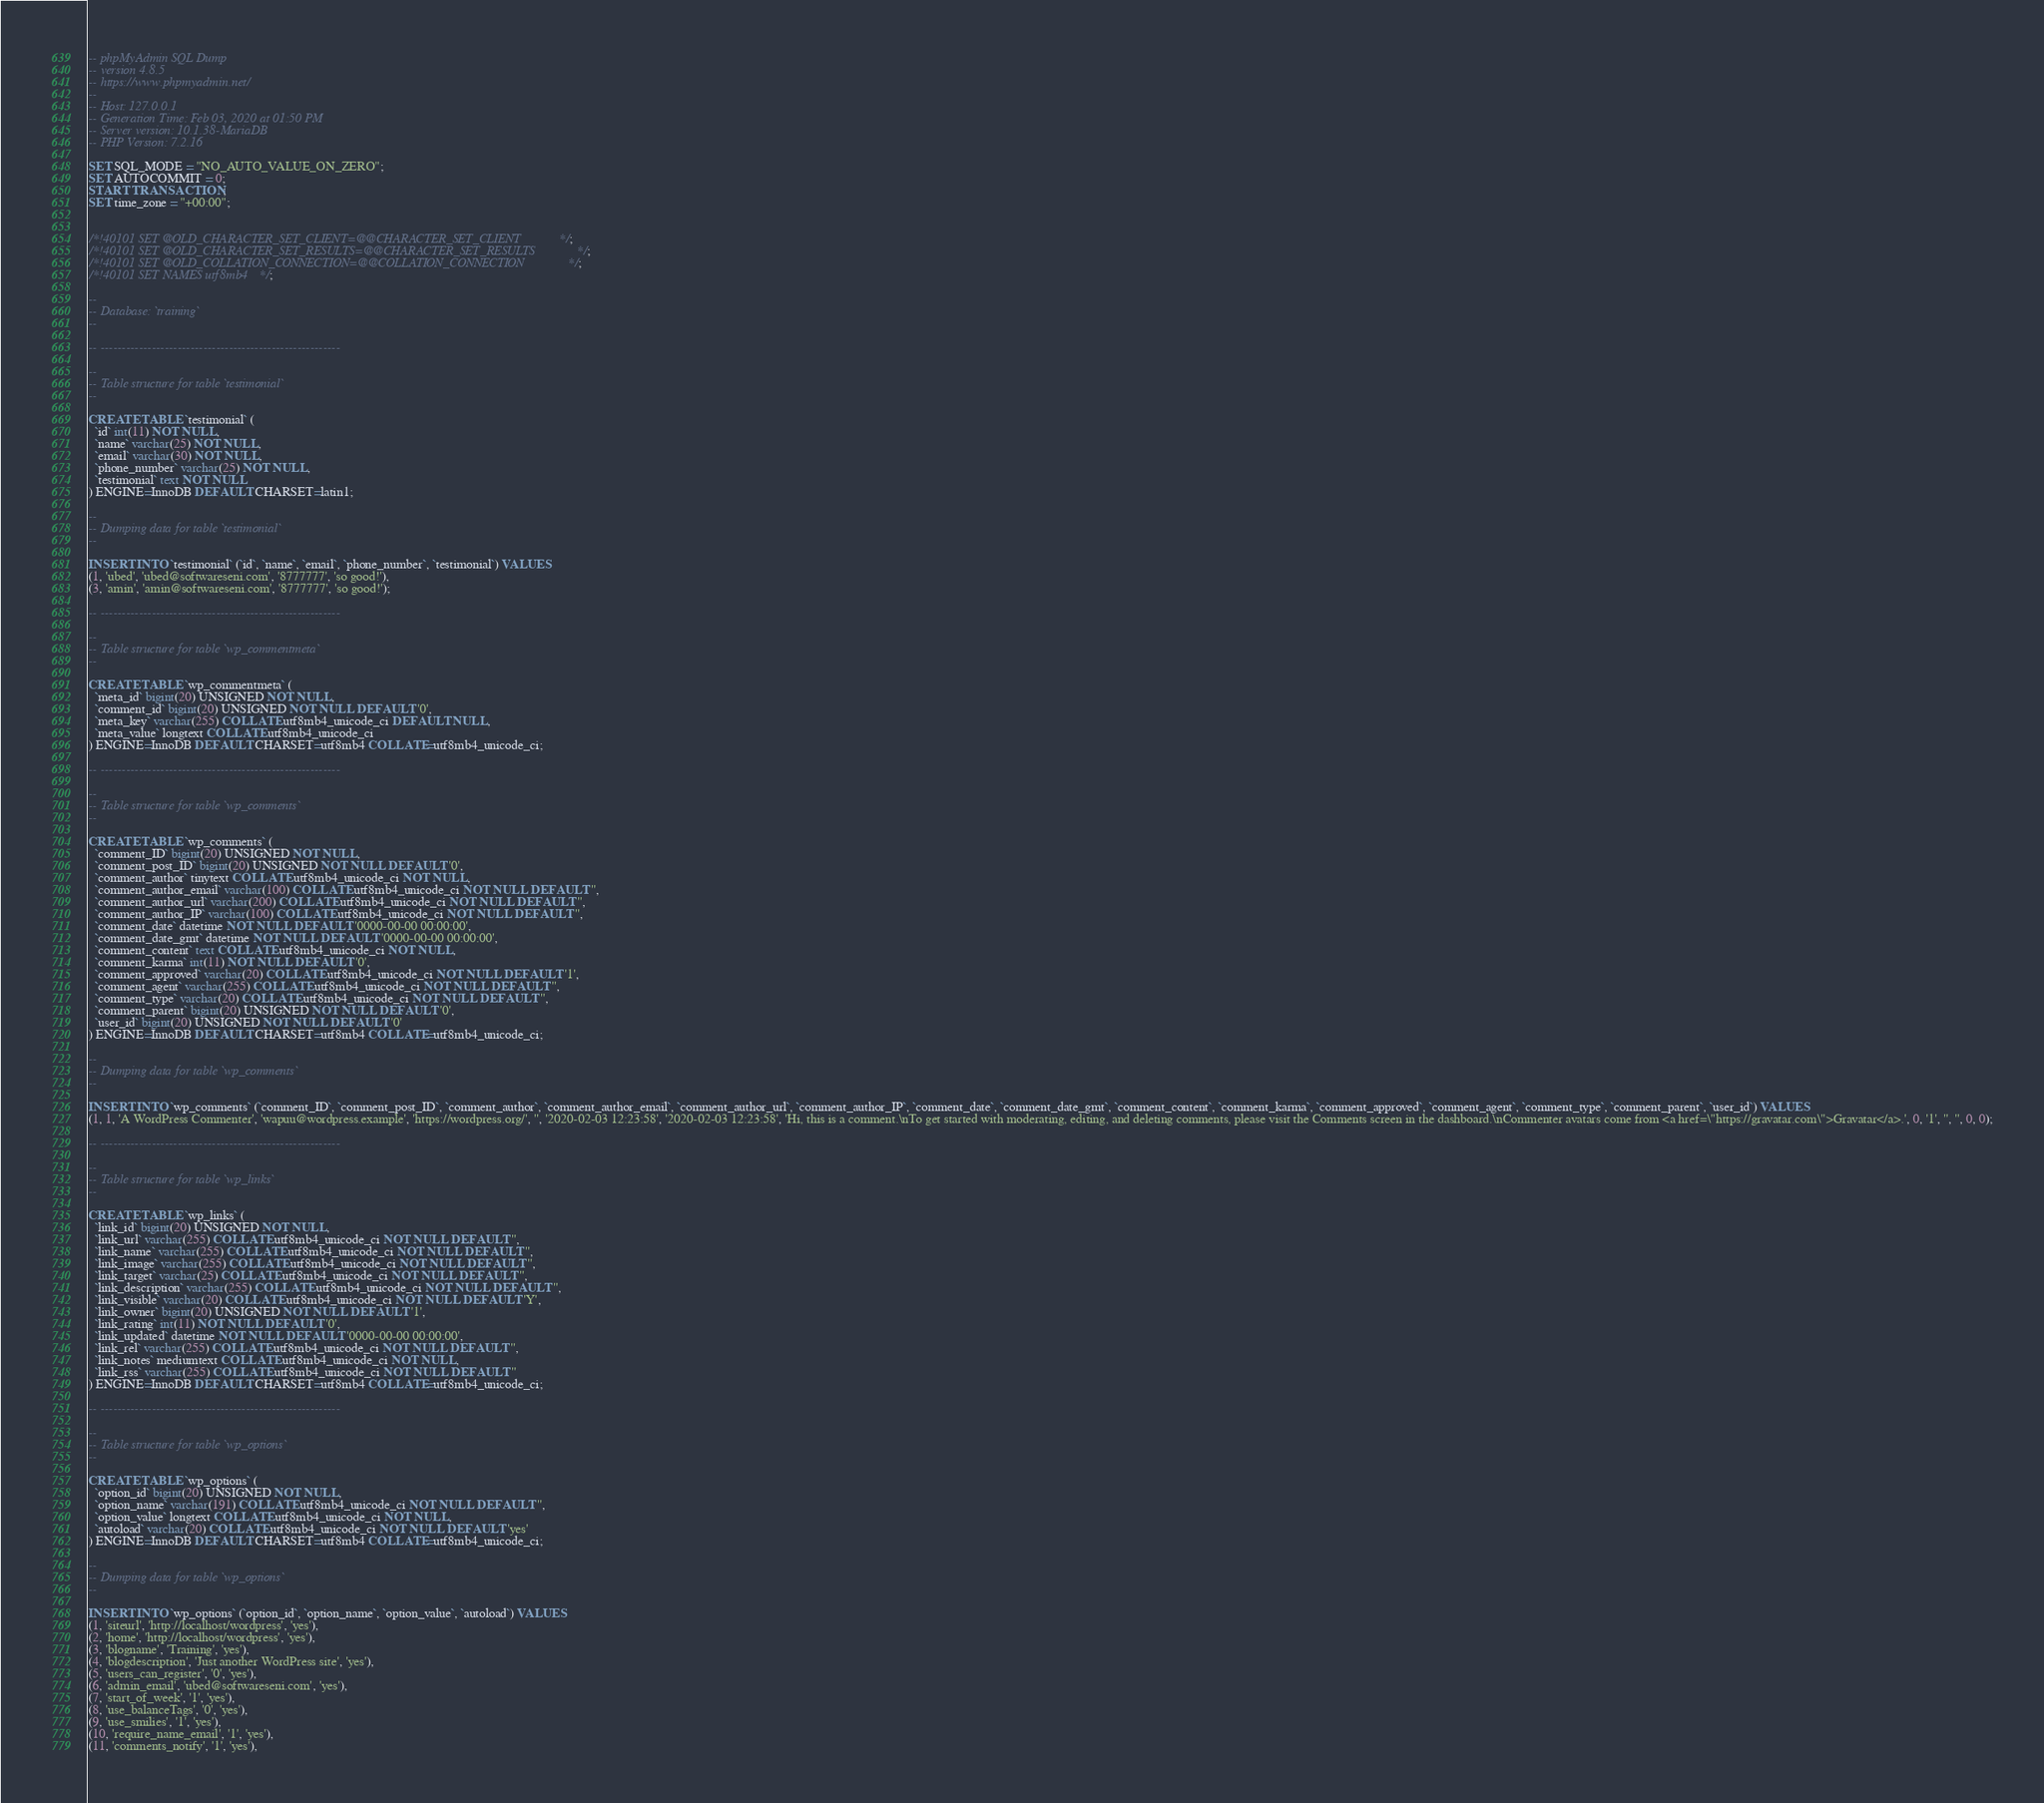Convert code to text. <code><loc_0><loc_0><loc_500><loc_500><_SQL_>-- phpMyAdmin SQL Dump
-- version 4.8.5
-- https://www.phpmyadmin.net/
--
-- Host: 127.0.0.1
-- Generation Time: Feb 03, 2020 at 01:50 PM
-- Server version: 10.1.38-MariaDB
-- PHP Version: 7.2.16

SET SQL_MODE = "NO_AUTO_VALUE_ON_ZERO";
SET AUTOCOMMIT = 0;
START TRANSACTION;
SET time_zone = "+00:00";


/*!40101 SET @OLD_CHARACTER_SET_CLIENT=@@CHARACTER_SET_CLIENT */;
/*!40101 SET @OLD_CHARACTER_SET_RESULTS=@@CHARACTER_SET_RESULTS */;
/*!40101 SET @OLD_COLLATION_CONNECTION=@@COLLATION_CONNECTION */;
/*!40101 SET NAMES utf8mb4 */;

--
-- Database: `training`
--

-- --------------------------------------------------------

--
-- Table structure for table `testimonial`
--

CREATE TABLE `testimonial` (
  `id` int(11) NOT NULL,
  `name` varchar(25) NOT NULL,
  `email` varchar(30) NOT NULL,
  `phone_number` varchar(25) NOT NULL,
  `testimonial` text NOT NULL
) ENGINE=InnoDB DEFAULT CHARSET=latin1;

--
-- Dumping data for table `testimonial`
--

INSERT INTO `testimonial` (`id`, `name`, `email`, `phone_number`, `testimonial`) VALUES
(1, 'ubed', 'ubed@softwareseni.com', '8777777', 'so good!'),
(3, 'amin', 'amin@softwareseni.com', '8777777', 'so good!');

-- --------------------------------------------------------

--
-- Table structure for table `wp_commentmeta`
--

CREATE TABLE `wp_commentmeta` (
  `meta_id` bigint(20) UNSIGNED NOT NULL,
  `comment_id` bigint(20) UNSIGNED NOT NULL DEFAULT '0',
  `meta_key` varchar(255) COLLATE utf8mb4_unicode_ci DEFAULT NULL,
  `meta_value` longtext COLLATE utf8mb4_unicode_ci
) ENGINE=InnoDB DEFAULT CHARSET=utf8mb4 COLLATE=utf8mb4_unicode_ci;

-- --------------------------------------------------------

--
-- Table structure for table `wp_comments`
--

CREATE TABLE `wp_comments` (
  `comment_ID` bigint(20) UNSIGNED NOT NULL,
  `comment_post_ID` bigint(20) UNSIGNED NOT NULL DEFAULT '0',
  `comment_author` tinytext COLLATE utf8mb4_unicode_ci NOT NULL,
  `comment_author_email` varchar(100) COLLATE utf8mb4_unicode_ci NOT NULL DEFAULT '',
  `comment_author_url` varchar(200) COLLATE utf8mb4_unicode_ci NOT NULL DEFAULT '',
  `comment_author_IP` varchar(100) COLLATE utf8mb4_unicode_ci NOT NULL DEFAULT '',
  `comment_date` datetime NOT NULL DEFAULT '0000-00-00 00:00:00',
  `comment_date_gmt` datetime NOT NULL DEFAULT '0000-00-00 00:00:00',
  `comment_content` text COLLATE utf8mb4_unicode_ci NOT NULL,
  `comment_karma` int(11) NOT NULL DEFAULT '0',
  `comment_approved` varchar(20) COLLATE utf8mb4_unicode_ci NOT NULL DEFAULT '1',
  `comment_agent` varchar(255) COLLATE utf8mb4_unicode_ci NOT NULL DEFAULT '',
  `comment_type` varchar(20) COLLATE utf8mb4_unicode_ci NOT NULL DEFAULT '',
  `comment_parent` bigint(20) UNSIGNED NOT NULL DEFAULT '0',
  `user_id` bigint(20) UNSIGNED NOT NULL DEFAULT '0'
) ENGINE=InnoDB DEFAULT CHARSET=utf8mb4 COLLATE=utf8mb4_unicode_ci;

--
-- Dumping data for table `wp_comments`
--

INSERT INTO `wp_comments` (`comment_ID`, `comment_post_ID`, `comment_author`, `comment_author_email`, `comment_author_url`, `comment_author_IP`, `comment_date`, `comment_date_gmt`, `comment_content`, `comment_karma`, `comment_approved`, `comment_agent`, `comment_type`, `comment_parent`, `user_id`) VALUES
(1, 1, 'A WordPress Commenter', 'wapuu@wordpress.example', 'https://wordpress.org/', '', '2020-02-03 12:23:58', '2020-02-03 12:23:58', 'Hi, this is a comment.\nTo get started with moderating, editing, and deleting comments, please visit the Comments screen in the dashboard.\nCommenter avatars come from <a href=\"https://gravatar.com\">Gravatar</a>.', 0, '1', '', '', 0, 0);

-- --------------------------------------------------------

--
-- Table structure for table `wp_links`
--

CREATE TABLE `wp_links` (
  `link_id` bigint(20) UNSIGNED NOT NULL,
  `link_url` varchar(255) COLLATE utf8mb4_unicode_ci NOT NULL DEFAULT '',
  `link_name` varchar(255) COLLATE utf8mb4_unicode_ci NOT NULL DEFAULT '',
  `link_image` varchar(255) COLLATE utf8mb4_unicode_ci NOT NULL DEFAULT '',
  `link_target` varchar(25) COLLATE utf8mb4_unicode_ci NOT NULL DEFAULT '',
  `link_description` varchar(255) COLLATE utf8mb4_unicode_ci NOT NULL DEFAULT '',
  `link_visible` varchar(20) COLLATE utf8mb4_unicode_ci NOT NULL DEFAULT 'Y',
  `link_owner` bigint(20) UNSIGNED NOT NULL DEFAULT '1',
  `link_rating` int(11) NOT NULL DEFAULT '0',
  `link_updated` datetime NOT NULL DEFAULT '0000-00-00 00:00:00',
  `link_rel` varchar(255) COLLATE utf8mb4_unicode_ci NOT NULL DEFAULT '',
  `link_notes` mediumtext COLLATE utf8mb4_unicode_ci NOT NULL,
  `link_rss` varchar(255) COLLATE utf8mb4_unicode_ci NOT NULL DEFAULT ''
) ENGINE=InnoDB DEFAULT CHARSET=utf8mb4 COLLATE=utf8mb4_unicode_ci;

-- --------------------------------------------------------

--
-- Table structure for table `wp_options`
--

CREATE TABLE `wp_options` (
  `option_id` bigint(20) UNSIGNED NOT NULL,
  `option_name` varchar(191) COLLATE utf8mb4_unicode_ci NOT NULL DEFAULT '',
  `option_value` longtext COLLATE utf8mb4_unicode_ci NOT NULL,
  `autoload` varchar(20) COLLATE utf8mb4_unicode_ci NOT NULL DEFAULT 'yes'
) ENGINE=InnoDB DEFAULT CHARSET=utf8mb4 COLLATE=utf8mb4_unicode_ci;

--
-- Dumping data for table `wp_options`
--

INSERT INTO `wp_options` (`option_id`, `option_name`, `option_value`, `autoload`) VALUES
(1, 'siteurl', 'http://localhost/wordpress', 'yes'),
(2, 'home', 'http://localhost/wordpress', 'yes'),
(3, 'blogname', 'Training', 'yes'),
(4, 'blogdescription', 'Just another WordPress site', 'yes'),
(5, 'users_can_register', '0', 'yes'),
(6, 'admin_email', 'ubed@softwareseni.com', 'yes'),
(7, 'start_of_week', '1', 'yes'),
(8, 'use_balanceTags', '0', 'yes'),
(9, 'use_smilies', '1', 'yes'),
(10, 'require_name_email', '1', 'yes'),
(11, 'comments_notify', '1', 'yes'),</code> 